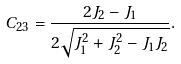<formula> <loc_0><loc_0><loc_500><loc_500>C _ { 2 3 } = \frac { 2 J _ { 2 } - J _ { 1 } } { 2 \sqrt { J _ { 1 } ^ { 2 } + J _ { 2 } ^ { 2 } - J _ { 1 } J _ { 2 } } } .</formula> 